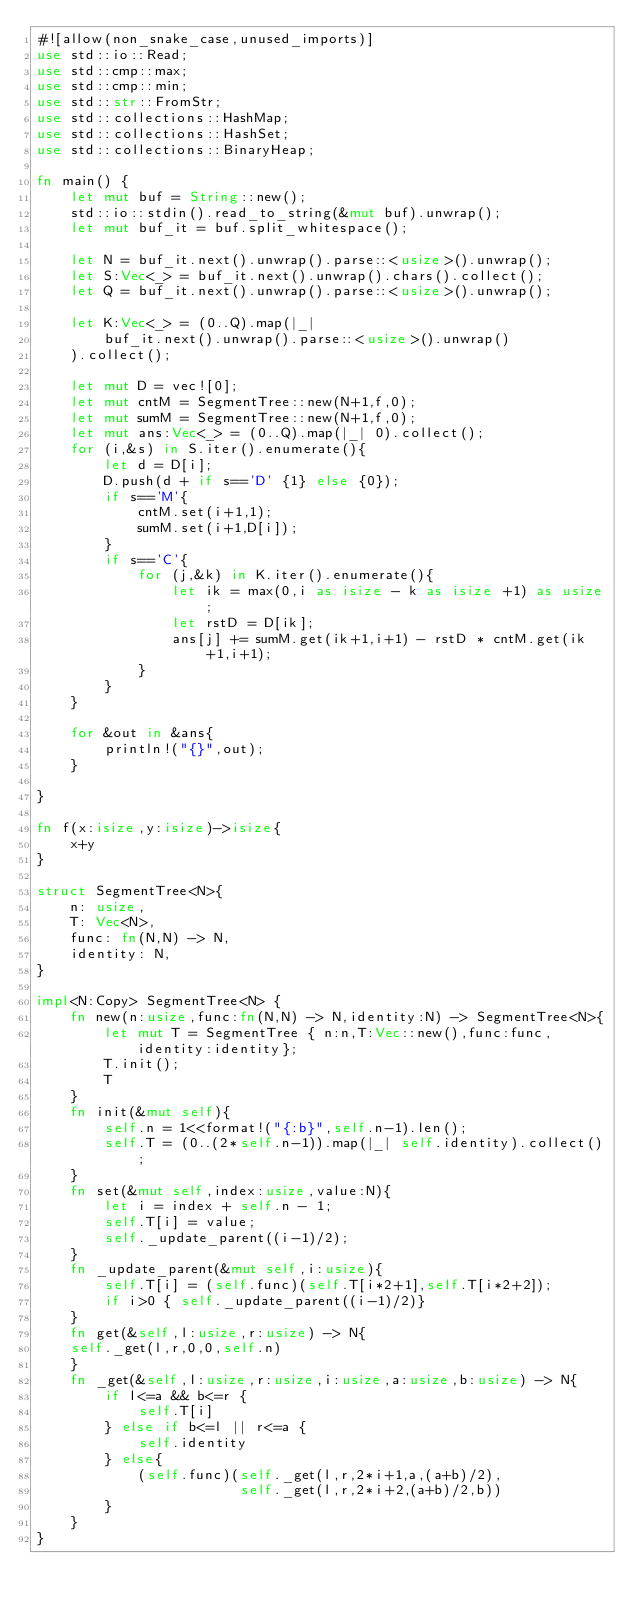<code> <loc_0><loc_0><loc_500><loc_500><_Rust_>#![allow(non_snake_case,unused_imports)]
use std::io::Read;
use std::cmp::max;
use std::cmp::min;
use std::str::FromStr;
use std::collections::HashMap;
use std::collections::HashSet;
use std::collections::BinaryHeap;

fn main() {
    let mut buf = String::new();
    std::io::stdin().read_to_string(&mut buf).unwrap();
    let mut buf_it = buf.split_whitespace();

    let N = buf_it.next().unwrap().parse::<usize>().unwrap();
    let S:Vec<_> = buf_it.next().unwrap().chars().collect();
    let Q = buf_it.next().unwrap().parse::<usize>().unwrap();

    let K:Vec<_> = (0..Q).map(|_|
        buf_it.next().unwrap().parse::<usize>().unwrap()
    ).collect();

    let mut D = vec![0];
    let mut cntM = SegmentTree::new(N+1,f,0);
    let mut sumM = SegmentTree::new(N+1,f,0);
    let mut ans:Vec<_> = (0..Q).map(|_| 0).collect();
    for (i,&s) in S.iter().enumerate(){
        let d = D[i];
        D.push(d + if s=='D' {1} else {0});
        if s=='M'{
            cntM.set(i+1,1);
            sumM.set(i+1,D[i]);
        }
        if s=='C'{
            for (j,&k) in K.iter().enumerate(){
                let ik = max(0,i as isize - k as isize +1) as usize;
                let rstD = D[ik];
                ans[j] += sumM.get(ik+1,i+1) - rstD * cntM.get(ik+1,i+1);
            }
        }
    }

    for &out in &ans{
        println!("{}",out);
    }

}

fn f(x:isize,y:isize)->isize{
    x+y
}

struct SegmentTree<N>{
    n: usize,
    T: Vec<N>,
    func: fn(N,N) -> N,
    identity: N,
}

impl<N:Copy> SegmentTree<N> {
    fn new(n:usize,func:fn(N,N) -> N,identity:N) -> SegmentTree<N>{
        let mut T = SegmentTree { n:n,T:Vec::new(),func:func,identity:identity};
        T.init();
        T
    }
    fn init(&mut self){
        self.n = 1<<format!("{:b}",self.n-1).len();
        self.T = (0..(2*self.n-1)).map(|_| self.identity).collect();
    }
    fn set(&mut self,index:usize,value:N){
        let i = index + self.n - 1;
        self.T[i] = value;
        self._update_parent((i-1)/2);
    }
    fn _update_parent(&mut self,i:usize){
        self.T[i] = (self.func)(self.T[i*2+1],self.T[i*2+2]);
        if i>0 { self._update_parent((i-1)/2)}
    }
    fn get(&self,l:usize,r:usize) -> N{
    self._get(l,r,0,0,self.n)
    }
    fn _get(&self,l:usize,r:usize,i:usize,a:usize,b:usize) -> N{
        if l<=a && b<=r {
            self.T[i]
        } else if b<=l || r<=a {
            self.identity
        } else{
            (self.func)(self._get(l,r,2*i+1,a,(a+b)/2),
                        self._get(l,r,2*i+2,(a+b)/2,b))
        }
    }
}</code> 